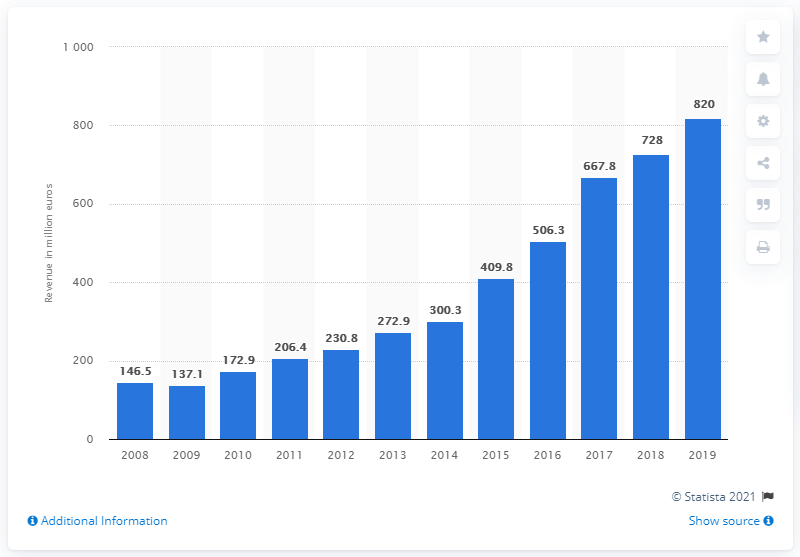Point out several critical features in this image. In 2019, Engel & Völkers generated approximately 820 million revenue. 